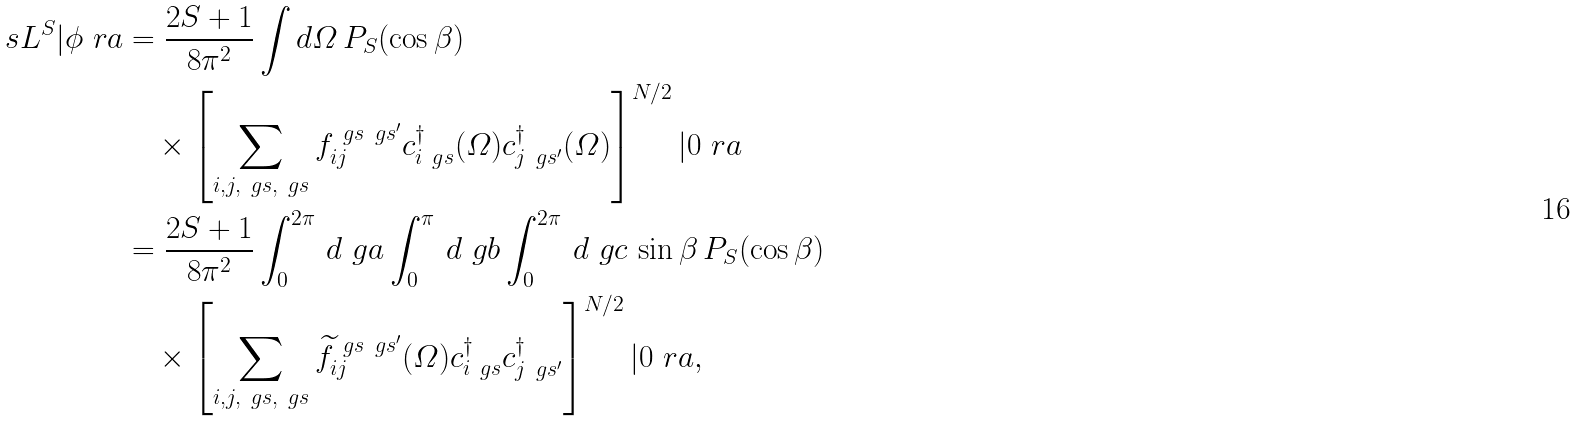<formula> <loc_0><loc_0><loc_500><loc_500>\ s L ^ { S } | \phi \ r a & = \frac { 2 S + 1 } { 8 \pi ^ { 2 } } \int d \varOmega \, P _ { S } ( \cos \beta ) \\ & \quad \times \left [ \sum _ { i , j , \ g s , \ g s } f _ { i j } ^ { \ g s \ g s ^ { \prime } } c _ { i \ g s } ^ { \dag } ( \varOmega ) c _ { j \ g s ^ { \prime } } ^ { \dag } ( \varOmega ) \right ] ^ { N / 2 } | 0 \ r a \\ & = \frac { 2 S + 1 } { 8 \pi ^ { 2 } } \int _ { 0 } ^ { 2 \pi } \, d \ g a \int _ { 0 } ^ { \pi } \, d \ g b \int _ { 0 } ^ { 2 \pi } \, d \ g c \, \sin \beta \, P _ { S } ( \cos \beta ) \\ & \quad \times \left [ \sum _ { i , j , \ g s , \ g s } \widetilde { f } _ { i j } ^ { \ g s \ g s ^ { \prime } } ( \varOmega ) c _ { i \ g s } ^ { \dag } c _ { j \ g s ^ { \prime } } ^ { \dag } \right ] ^ { N / 2 } | 0 \ r a ,</formula> 